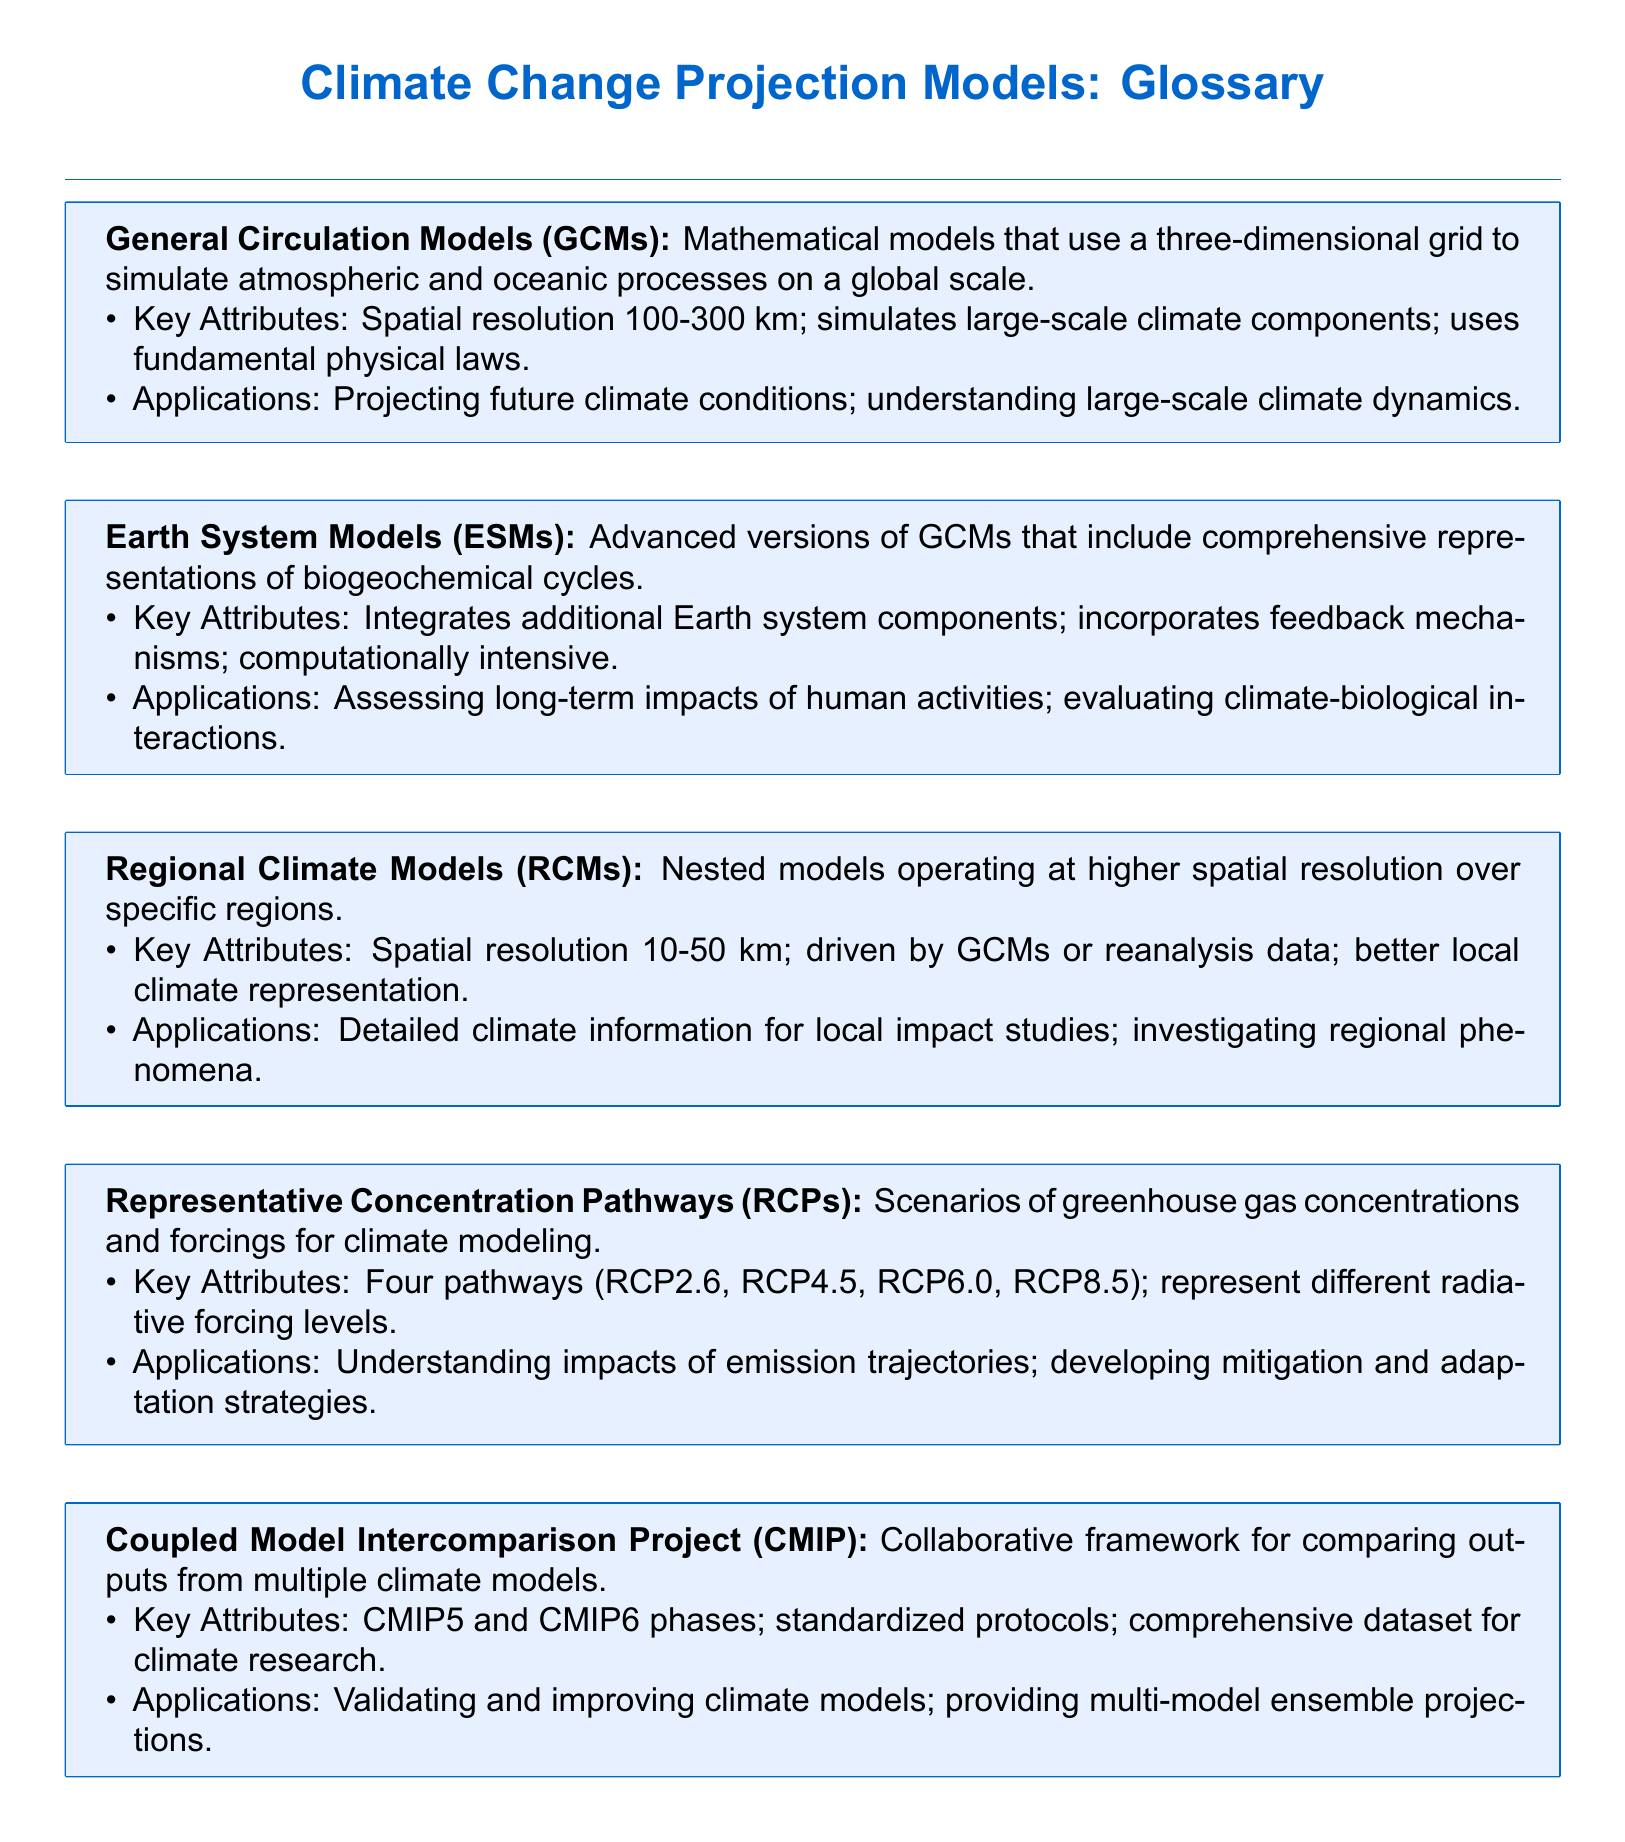What are General Circulation Models also known as? The document defines General Circulation Models and does not mention any alternative names.
Answer: General Circulation Models What is the spatial resolution range of GCMs? The document states that the spatial resolution of GCMs is between 100-300 km.
Answer: 100-300 km How many Representative Concentration Pathways are mentioned? The document lists four Representative Concentration Pathways in its definition.
Answer: Four What are Earth System Models advanced versions of? The document clearly states that Earth System Models are advanced versions of General Circulation Models.
Answer: General Circulation Models What is the spatial resolution range of Regional Climate Models? According to the document, the spatial resolution of Regional Climate Models ranges from 10-50 km.
Answer: 10-50 km Which project provides a dataset for climate research? The document names the Coupled Model Intercomparison Project as the collaborative framework for climate research.
Answer: Coupled Model Intercomparison Project What do RCP scenarios represent? The document describes Representative Concentration Pathways as scenarios of greenhouse gas concentrations and forcings.
Answer: Greenhouse gas concentrations and forcings What is a key attribute of Earth System Models regarding their computational needs? The document indicates that Earth System Models are computationally intensive as a key attribute.
Answer: Computationally intensive 